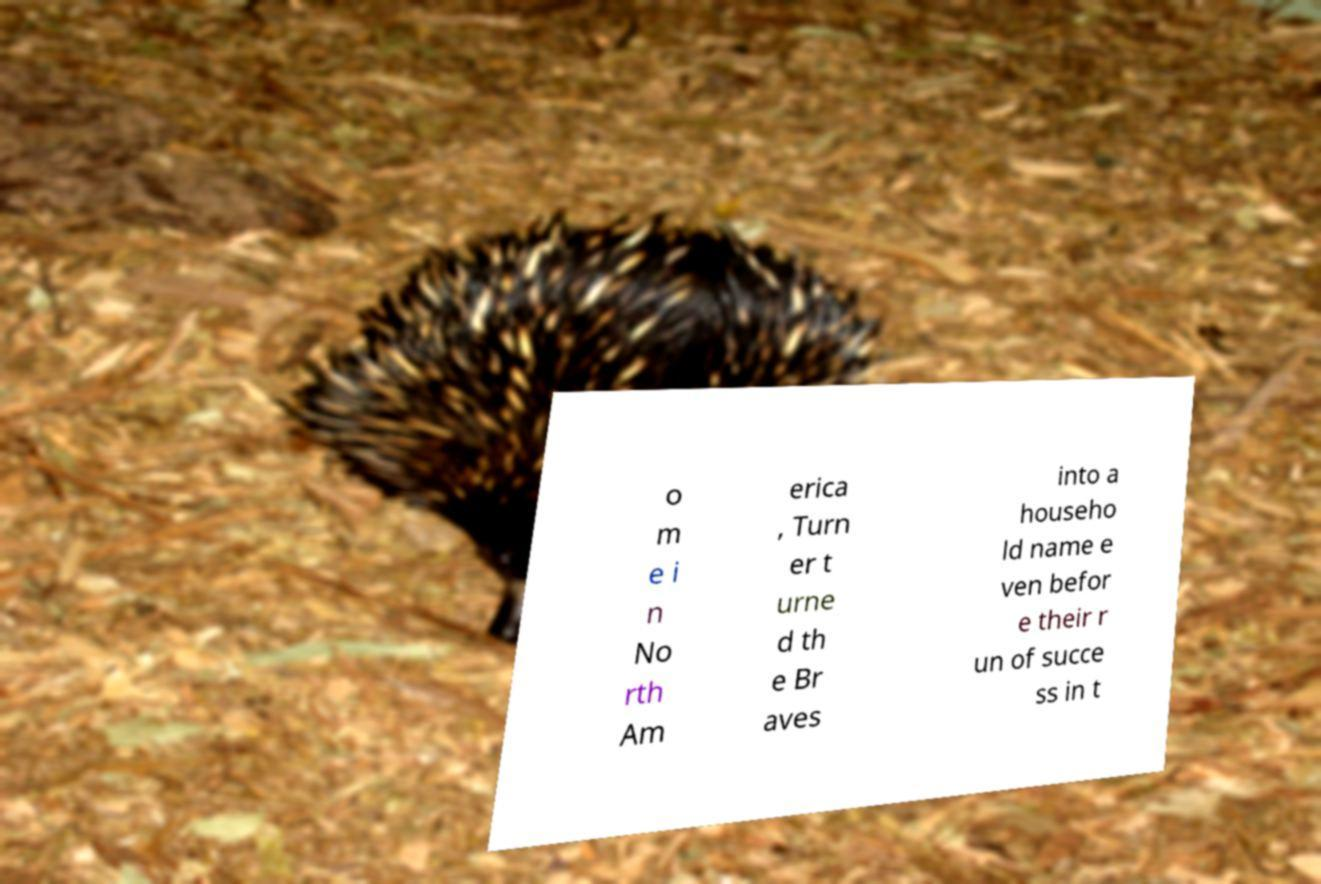For documentation purposes, I need the text within this image transcribed. Could you provide that? o m e i n No rth Am erica , Turn er t urne d th e Br aves into a househo ld name e ven befor e their r un of succe ss in t 